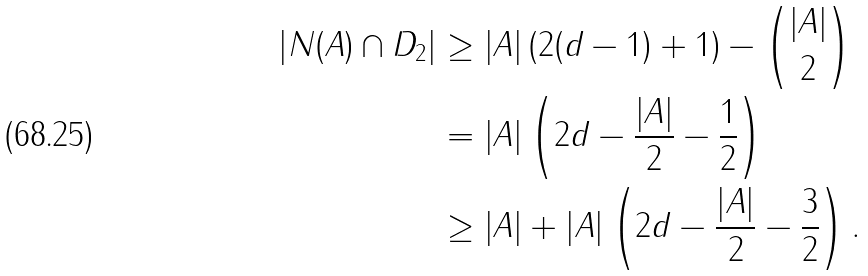Convert formula to latex. <formula><loc_0><loc_0><loc_500><loc_500>\left | N ( A ) \cap D _ { 2 } \right | & \geq \left | A \right | \left ( 2 ( d - 1 ) + 1 \right ) - { \left | A \right | \choose 2 } \\ & = \left | A \right | \left ( 2 d - \frac { \left | A \right | } { 2 } - \frac { 1 } { 2 } \right ) \\ & \geq \left | A \right | + \left | A \right | \left ( 2 d - \frac { \left | A \right | } { 2 } - \frac { 3 } { 2 } \right ) .</formula> 